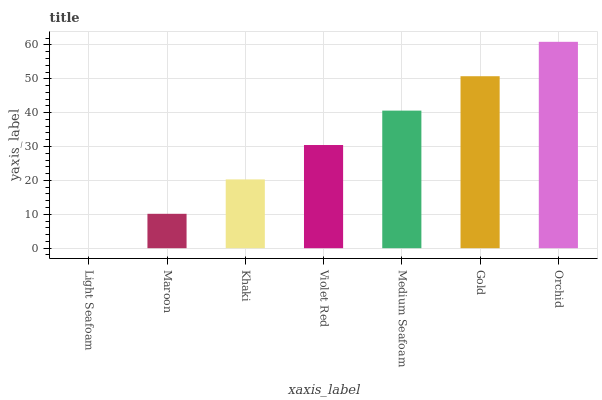Is Light Seafoam the minimum?
Answer yes or no. Yes. Is Orchid the maximum?
Answer yes or no. Yes. Is Maroon the minimum?
Answer yes or no. No. Is Maroon the maximum?
Answer yes or no. No. Is Maroon greater than Light Seafoam?
Answer yes or no. Yes. Is Light Seafoam less than Maroon?
Answer yes or no. Yes. Is Light Seafoam greater than Maroon?
Answer yes or no. No. Is Maroon less than Light Seafoam?
Answer yes or no. No. Is Violet Red the high median?
Answer yes or no. Yes. Is Violet Red the low median?
Answer yes or no. Yes. Is Gold the high median?
Answer yes or no. No. Is Maroon the low median?
Answer yes or no. No. 